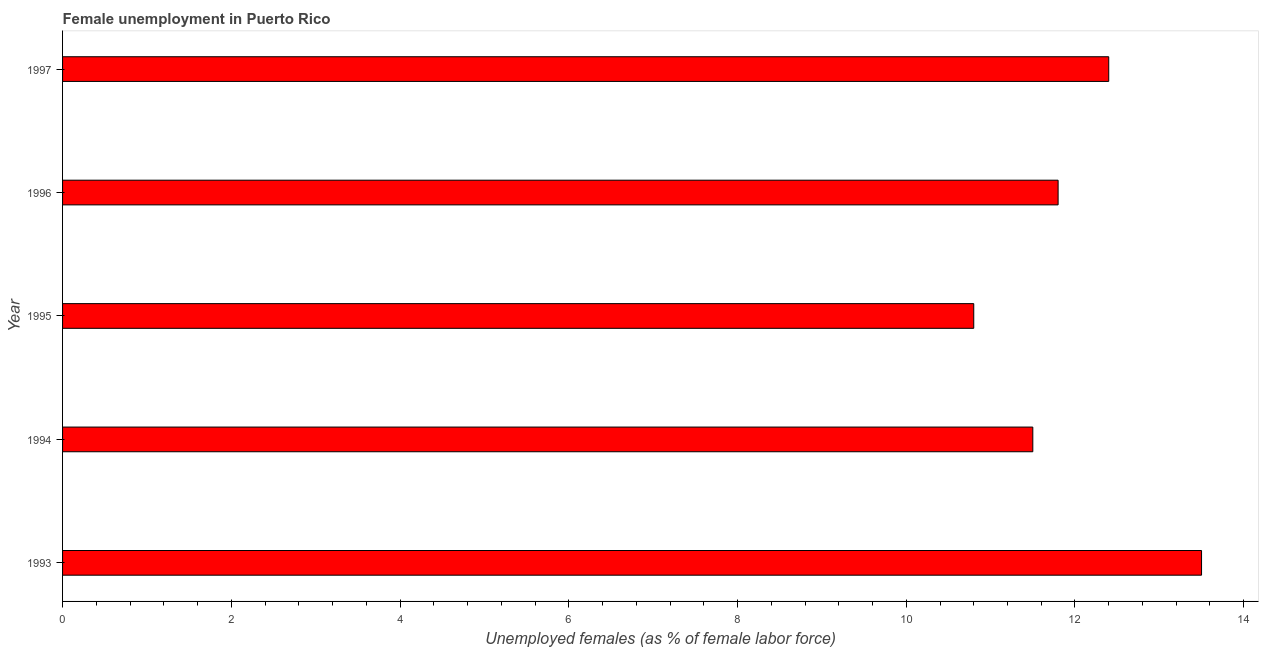Does the graph contain any zero values?
Provide a succinct answer. No. What is the title of the graph?
Your answer should be very brief. Female unemployment in Puerto Rico. What is the label or title of the X-axis?
Make the answer very short. Unemployed females (as % of female labor force). What is the label or title of the Y-axis?
Provide a succinct answer. Year. What is the unemployed females population in 1993?
Your response must be concise. 13.5. Across all years, what is the maximum unemployed females population?
Your answer should be compact. 13.5. Across all years, what is the minimum unemployed females population?
Provide a short and direct response. 10.8. In which year was the unemployed females population maximum?
Your answer should be compact. 1993. In which year was the unemployed females population minimum?
Your answer should be very brief. 1995. What is the sum of the unemployed females population?
Provide a short and direct response. 60. What is the difference between the unemployed females population in 1994 and 1996?
Provide a short and direct response. -0.3. What is the median unemployed females population?
Make the answer very short. 11.8. In how many years, is the unemployed females population greater than 5.6 %?
Offer a very short reply. 5. What is the ratio of the unemployed females population in 1993 to that in 1995?
Your response must be concise. 1.25. Is the unemployed females population in 1993 less than that in 1995?
Offer a terse response. No. Is the difference between the unemployed females population in 1995 and 1997 greater than the difference between any two years?
Your response must be concise. No. What is the difference between the highest and the lowest unemployed females population?
Provide a short and direct response. 2.7. In how many years, is the unemployed females population greater than the average unemployed females population taken over all years?
Your answer should be compact. 2. What is the difference between two consecutive major ticks on the X-axis?
Ensure brevity in your answer.  2. Are the values on the major ticks of X-axis written in scientific E-notation?
Keep it short and to the point. No. What is the Unemployed females (as % of female labor force) of 1993?
Ensure brevity in your answer.  13.5. What is the Unemployed females (as % of female labor force) in 1994?
Keep it short and to the point. 11.5. What is the Unemployed females (as % of female labor force) of 1995?
Provide a succinct answer. 10.8. What is the Unemployed females (as % of female labor force) of 1996?
Your answer should be very brief. 11.8. What is the Unemployed females (as % of female labor force) of 1997?
Your answer should be very brief. 12.4. What is the difference between the Unemployed females (as % of female labor force) in 1993 and 1996?
Make the answer very short. 1.7. What is the difference between the Unemployed females (as % of female labor force) in 1994 and 1996?
Your response must be concise. -0.3. What is the difference between the Unemployed females (as % of female labor force) in 1994 and 1997?
Keep it short and to the point. -0.9. What is the difference between the Unemployed females (as % of female labor force) in 1996 and 1997?
Provide a short and direct response. -0.6. What is the ratio of the Unemployed females (as % of female labor force) in 1993 to that in 1994?
Give a very brief answer. 1.17. What is the ratio of the Unemployed females (as % of female labor force) in 1993 to that in 1995?
Give a very brief answer. 1.25. What is the ratio of the Unemployed females (as % of female labor force) in 1993 to that in 1996?
Your response must be concise. 1.14. What is the ratio of the Unemployed females (as % of female labor force) in 1993 to that in 1997?
Provide a succinct answer. 1.09. What is the ratio of the Unemployed females (as % of female labor force) in 1994 to that in 1995?
Give a very brief answer. 1.06. What is the ratio of the Unemployed females (as % of female labor force) in 1994 to that in 1997?
Offer a very short reply. 0.93. What is the ratio of the Unemployed females (as % of female labor force) in 1995 to that in 1996?
Your answer should be compact. 0.92. What is the ratio of the Unemployed females (as % of female labor force) in 1995 to that in 1997?
Your answer should be compact. 0.87. What is the ratio of the Unemployed females (as % of female labor force) in 1996 to that in 1997?
Provide a short and direct response. 0.95. 